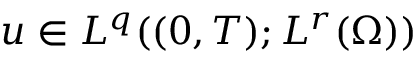<formula> <loc_0><loc_0><loc_500><loc_500>u \in L ^ { q } ( ( 0 , T ) ; L ^ { r } ( \Omega ) )</formula> 